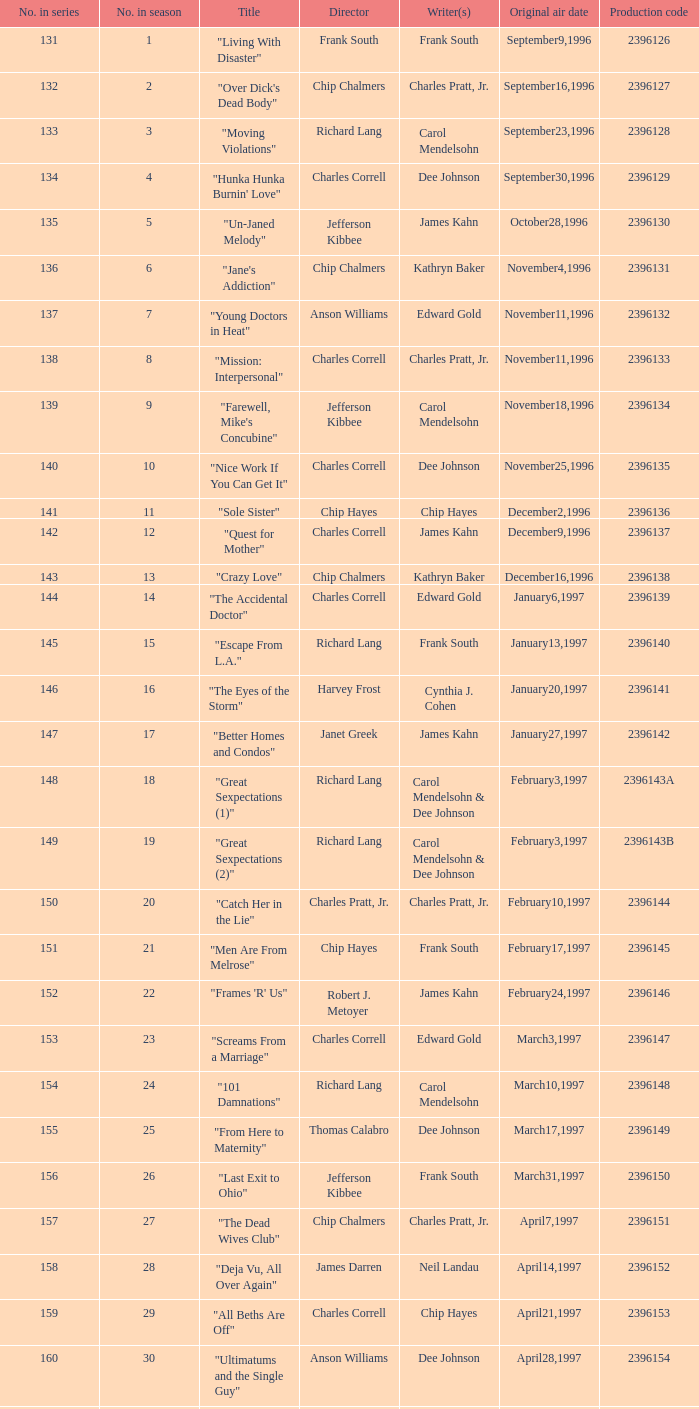Who directed the installment "great sexpectations (2)"? Richard Lang. 